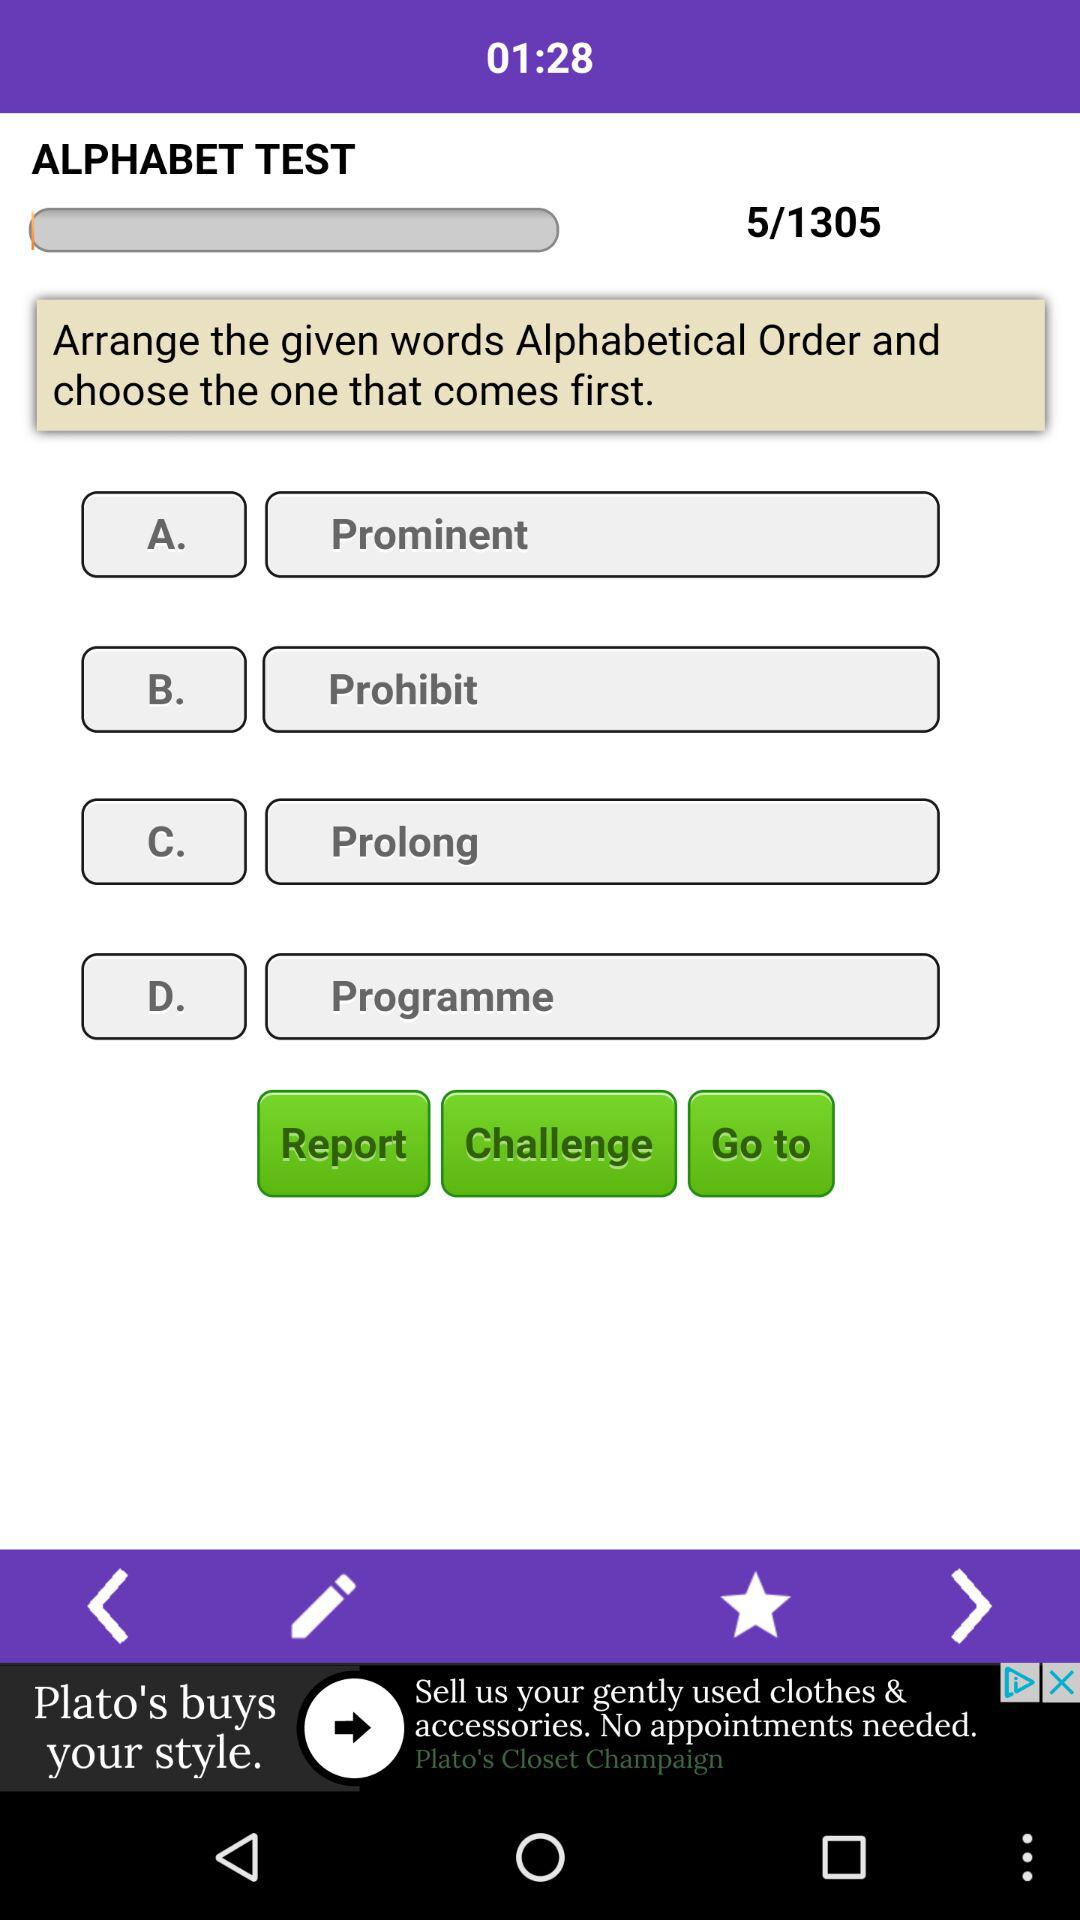What is the name of the test? The name of the test is "ALPHABET TEST". 